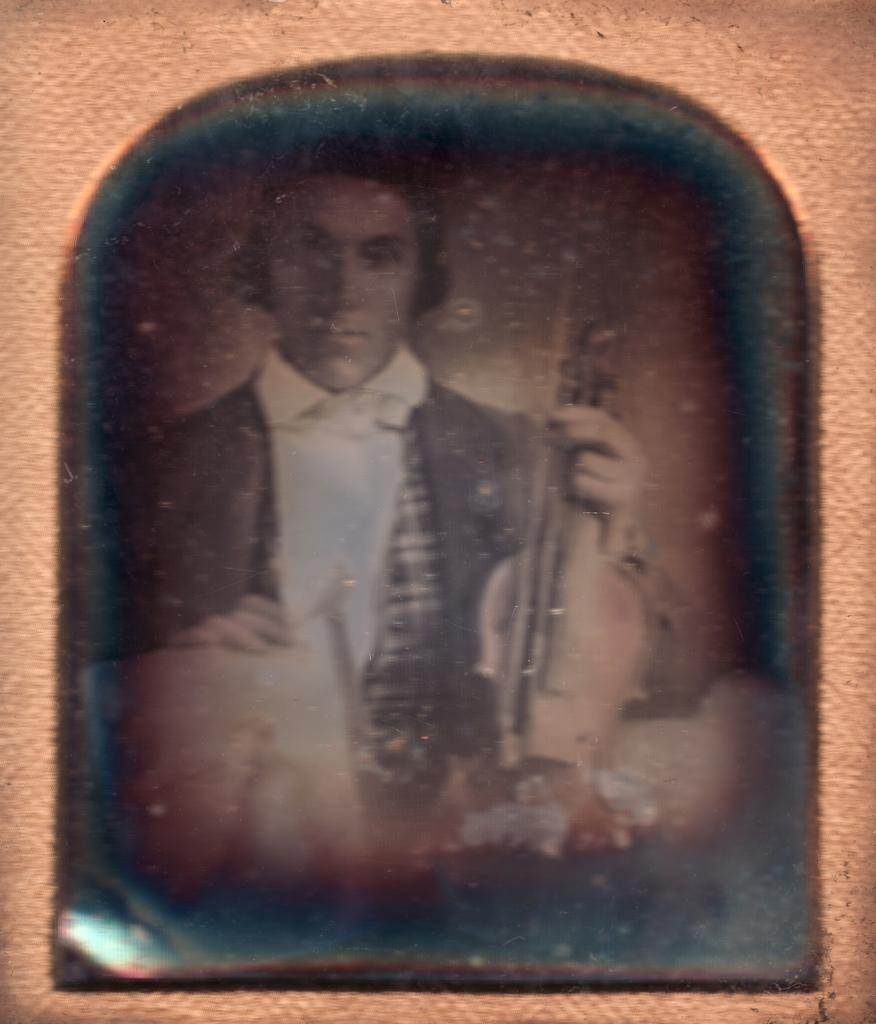What is the main subject of the image? The main subject of the image is a man. What is the man doing in the image? The man is holding a musical instrument in the image. What is the color scheme of the image? The image is black and white in color. How many bikes are parked next to the man in the image? There are no bikes present in the image; it only features a man holding a musical instrument. What type of beast can be seen in the background of the image? There is no beast present in the image; it is a black and white picture of a man holding a musical instrument. 